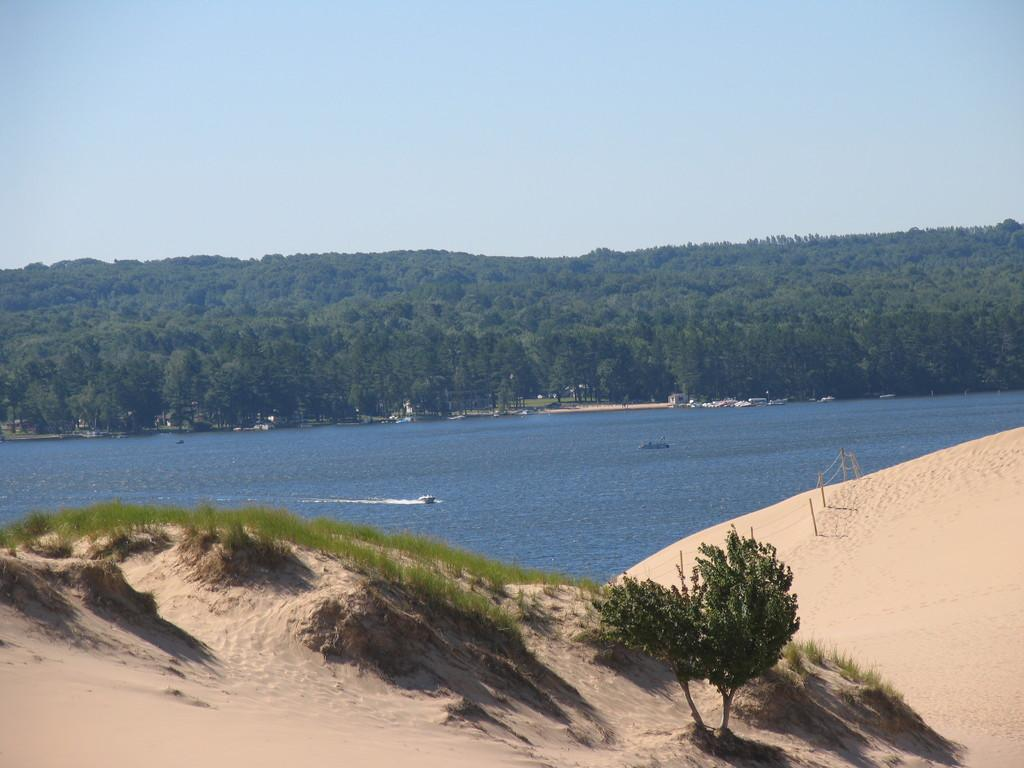What type of vegetation is present in the image? There are plants and trees in the image. What type of terrain is visible in the image? There is sand in the image. What is on the water in the image? There is a boat on the water in the image. What else can be seen in the image besides the plants, sand, and boat? There are some objects in the image. What can be seen in the background of the image? The sky is visible in the background of the image. Where is the shop located in the image? There is no shop present in the image. What type of print can be seen on the boat in the image? There is no print visible on the boat in the image. 